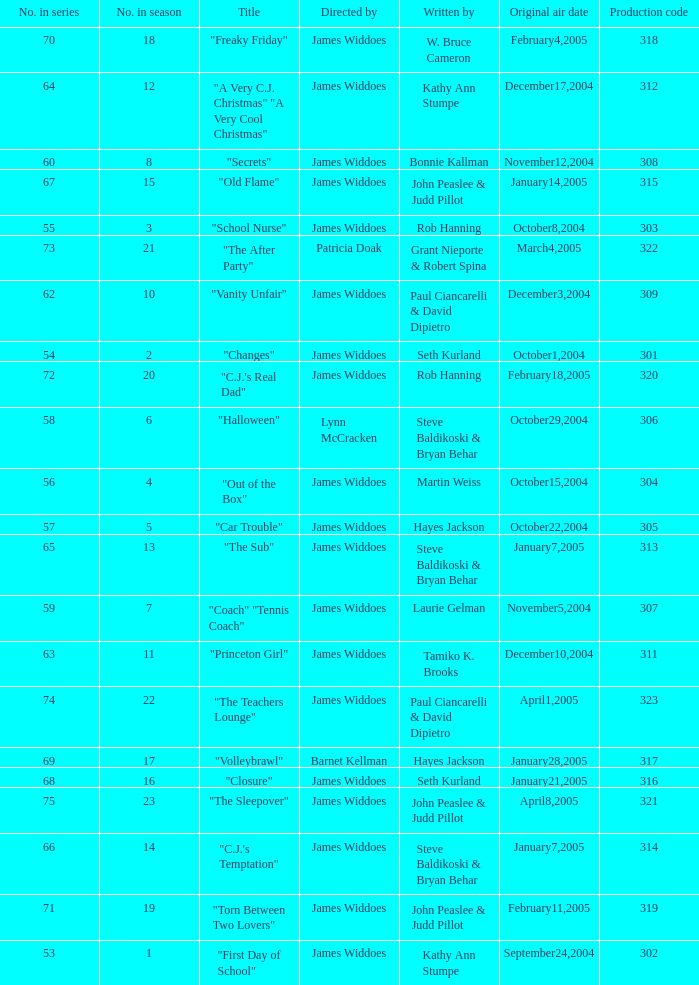How many production codes are there for "the sub"? 1.0. 